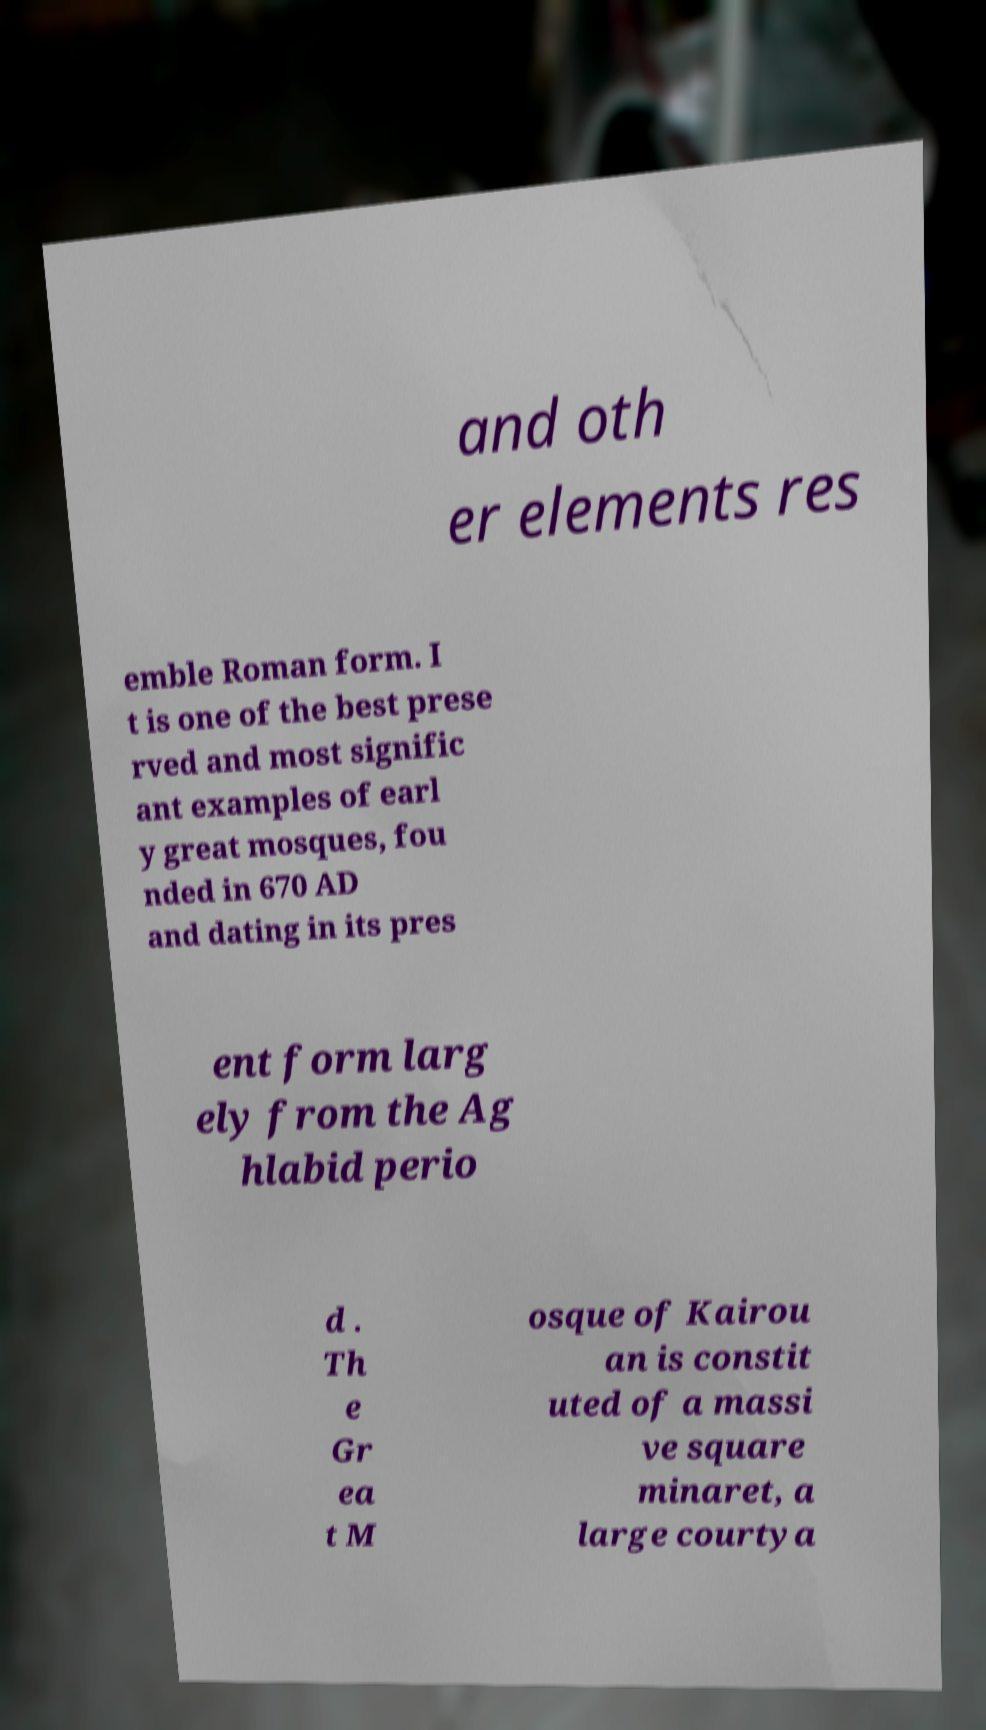There's text embedded in this image that I need extracted. Can you transcribe it verbatim? and oth er elements res emble Roman form. I t is one of the best prese rved and most signific ant examples of earl y great mosques, fou nded in 670 AD and dating in its pres ent form larg ely from the Ag hlabid perio d . Th e Gr ea t M osque of Kairou an is constit uted of a massi ve square minaret, a large courtya 